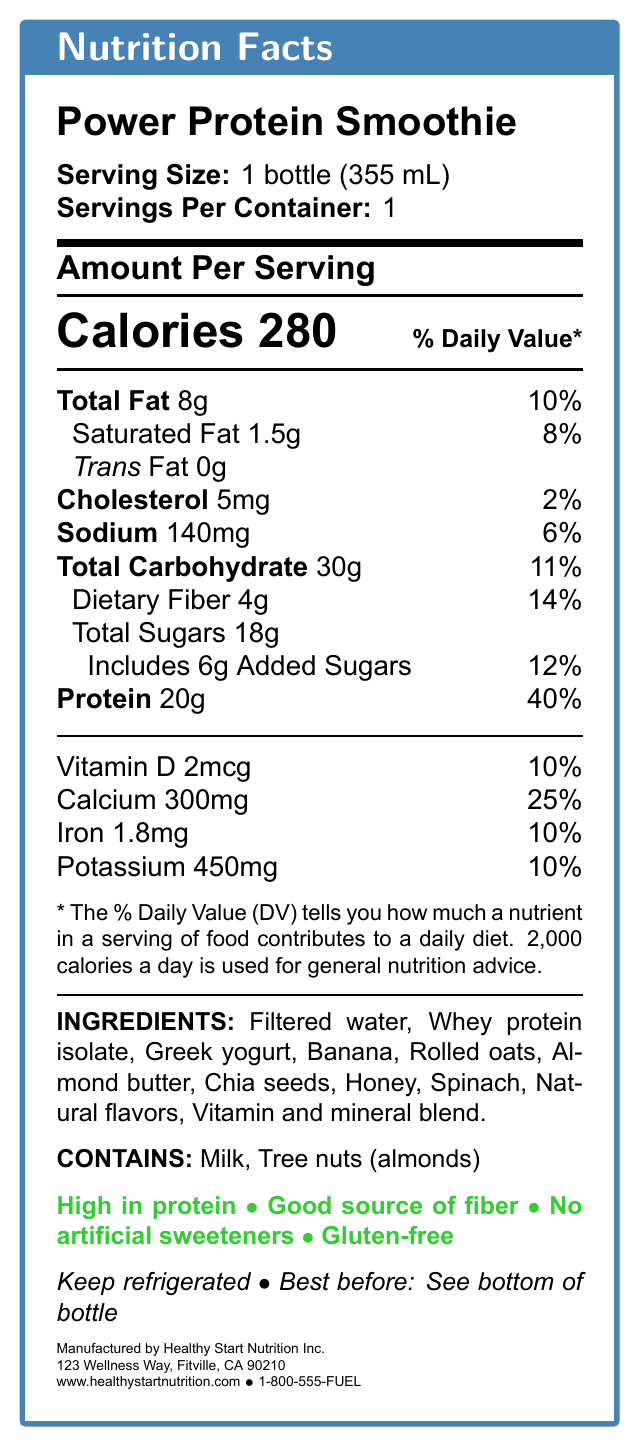What is the serving size of the Power Protein Smoothie? The serving size is explicitly mentioned in the document as "1 bottle (355 mL)".
Answer: 1 bottle (355 mL) How many calories are in one serving of the Power Protein Smoothie? The document states that each serving contains 280 calories.
Answer: 280 What is the total fat content and its daily value percentage in the smoothie? The document lists the total fat content as 8g, with a daily value percentage of 10%.
Answer: 8g, 10% How much protein does the smoothie contain? The protein content is clearly labeled as 20g in the document.
Answer: 20g What are the main allergens present in this smoothie? The allergens listed are milk and tree nuts (almonds).
Answer: Milk, Tree nuts (almonds) Which of the following ingredients is not listed in the document? A. Banana B. Chia seeds C. Blueberries D. Rolled oats The listed ingredients include Banana, Chia seeds, and Rolled oats, but not Blueberries.
Answer: C. Blueberries What is the percentage of daily value for dietary fiber in the smoothie? A. 10% B. 14% C. 25% D. 40% The document specifies that the daily value percentage for dietary fiber is 14%.
Answer: B. 14% Is the Power Protein Smoothie gluten-free? The document claims that the smoothie is gluten-free as one of its key attributes.
Answer: Yes Describe the main nutrition and ingredient information provided in the document. This summary encapsulates the nutrition facts, ingredients, allergen information, claims, and storage instructions indicated in the document.
Answer: The Power Protein Smoothie has a serving size of 1 bottle (355 mL), containing 280 calories, 8g of total fat (10% DV), 1.5g saturated fat (8% DV), 5mg cholesterol (2% DV), 140mg sodium (6% DV), 30g total carbohydrate (11% DV) including 4g dietary fiber (14% DV) and 18g total sugars of which 6g are added sugars (12% DV). It provides 20g of protein (40% DV). The document also lists essential vitamins and minerals, including Vitamin D, Calcium, Iron, and Potassium. The ingredients include filtered water, whey protein isolate, Greek yogurt, banana, rolled oats, almond butter, chia seeds, honey, spinach, natural flavors, and a vitamin and mineral blend. The drink contains milk and tree nuts (almonds) and is claimed to be high in protein, a good source of fiber, free of artificial sweeteners, and gluten-free. It should be kept refrigerated and has a "best before" date on the bottom of the bottle. The manufacturer is Healthy Start Nutrition Inc. What is the address of the manufacturer? The address provided in the document is "123 Wellness Way, Fitville, CA 90210".
Answer: 123 Wellness Way, Fitville, CA 90210 Can the total sugar content in the smoothie be divided into two parts, and if so, what are they? The document divides the total sugar content into 18g of total sugars, which includes 6g of added sugars.
Answer: Yes, Total Sugars: 18g (Includes 6g Added Sugars) What is the exact amount of calcium in one serving of the smoothie? The document lists the calcium content as 300mg per serving.
Answer: 300mg How many servings are contained in one bottle of the Power Protein Smoothie? The document clarifies that there is 1 serving per container.
Answer: 1 What is the manufacturer's website? The website provided in the document is www.healthystartnutrition.com.
Answer: www.healthystartnutrition.com What is the contact number for customer service? The contact number for customer service listed in the document is 1-800-555-FUEL.
Answer: 1-800-555-FUEL How much saturated fat is in the smoothie, and what is its daily value percentage? The document specifies that the smoothie contains 1.5g of saturated fat, with an 8% daily value.
Answer: 1.5g, 8% What is the percentage of daily value for iron in the smoothie? The iron content is listed as having a 10% daily value.
Answer: 10% Does the document provide information on when the smoothie was first manufactured? The document does not provide any historical manufacturing information.
Answer: Not enough information Given the ingredients and nutrition facts, would this smoothie be a good source of fiber? Why? The dietary fiber content is 4g, translating to 14% of the daily value, confirming it as a good source of fiber.
Answer: Yes, because it contains 4g of dietary fiber, which is 14% of the daily value. 